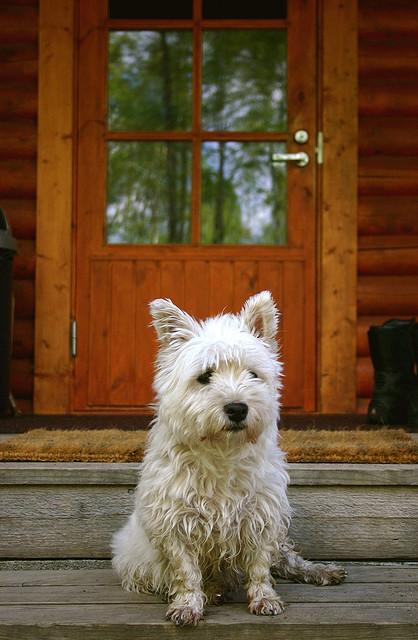What is the dog looking out of?
Give a very brief answer. Eyes. Are there tags on the dog collar?
Be succinct. No. Is the dog happy on the table?
Quick response, please. No. What breed of dog is this?
Quick response, please. Terrier. Is the dog sleeping?
Concise answer only. No. Does the dog need a bath?
Keep it brief. Yes. 